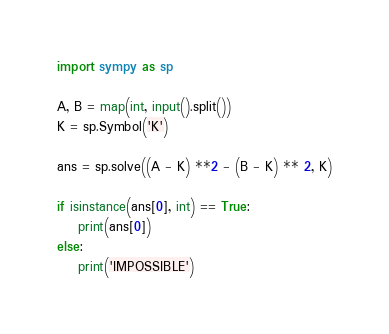Convert code to text. <code><loc_0><loc_0><loc_500><loc_500><_Python_>import sympy as sp

A, B = map(int, input().split())
K = sp.Symbol('K')

ans = sp.solve((A - K) **2 - (B - K) ** 2, K)

if isinstance(ans[0], int) == True:
    print(ans[0])
else:
    print('IMPOSSIBLE')</code> 